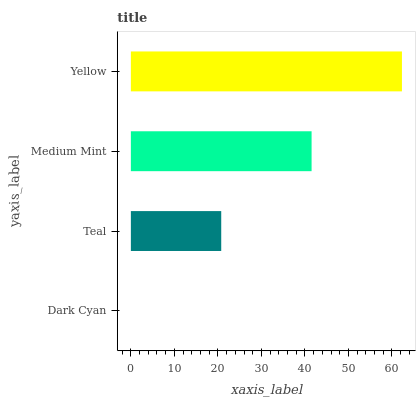Is Dark Cyan the minimum?
Answer yes or no. Yes. Is Yellow the maximum?
Answer yes or no. Yes. Is Teal the minimum?
Answer yes or no. No. Is Teal the maximum?
Answer yes or no. No. Is Teal greater than Dark Cyan?
Answer yes or no. Yes. Is Dark Cyan less than Teal?
Answer yes or no. Yes. Is Dark Cyan greater than Teal?
Answer yes or no. No. Is Teal less than Dark Cyan?
Answer yes or no. No. Is Medium Mint the high median?
Answer yes or no. Yes. Is Teal the low median?
Answer yes or no. Yes. Is Teal the high median?
Answer yes or no. No. Is Yellow the low median?
Answer yes or no. No. 